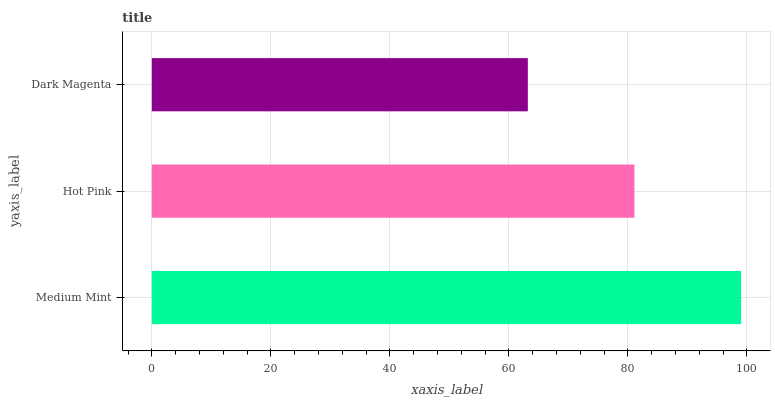Is Dark Magenta the minimum?
Answer yes or no. Yes. Is Medium Mint the maximum?
Answer yes or no. Yes. Is Hot Pink the minimum?
Answer yes or no. No. Is Hot Pink the maximum?
Answer yes or no. No. Is Medium Mint greater than Hot Pink?
Answer yes or no. Yes. Is Hot Pink less than Medium Mint?
Answer yes or no. Yes. Is Hot Pink greater than Medium Mint?
Answer yes or no. No. Is Medium Mint less than Hot Pink?
Answer yes or no. No. Is Hot Pink the high median?
Answer yes or no. Yes. Is Hot Pink the low median?
Answer yes or no. Yes. Is Dark Magenta the high median?
Answer yes or no. No. Is Dark Magenta the low median?
Answer yes or no. No. 